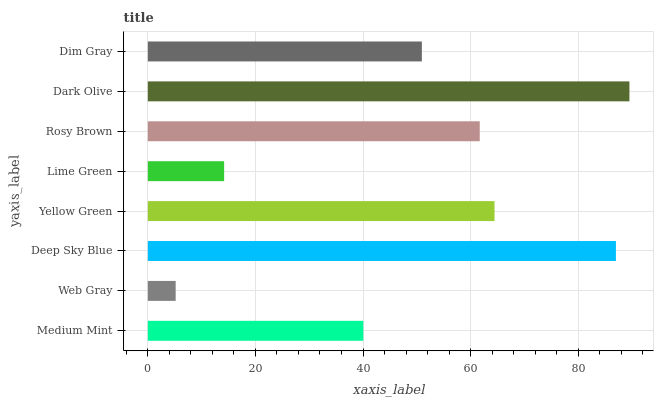Is Web Gray the minimum?
Answer yes or no. Yes. Is Dark Olive the maximum?
Answer yes or no. Yes. Is Deep Sky Blue the minimum?
Answer yes or no. No. Is Deep Sky Blue the maximum?
Answer yes or no. No. Is Deep Sky Blue greater than Web Gray?
Answer yes or no. Yes. Is Web Gray less than Deep Sky Blue?
Answer yes or no. Yes. Is Web Gray greater than Deep Sky Blue?
Answer yes or no. No. Is Deep Sky Blue less than Web Gray?
Answer yes or no. No. Is Rosy Brown the high median?
Answer yes or no. Yes. Is Dim Gray the low median?
Answer yes or no. Yes. Is Dim Gray the high median?
Answer yes or no. No. Is Yellow Green the low median?
Answer yes or no. No. 